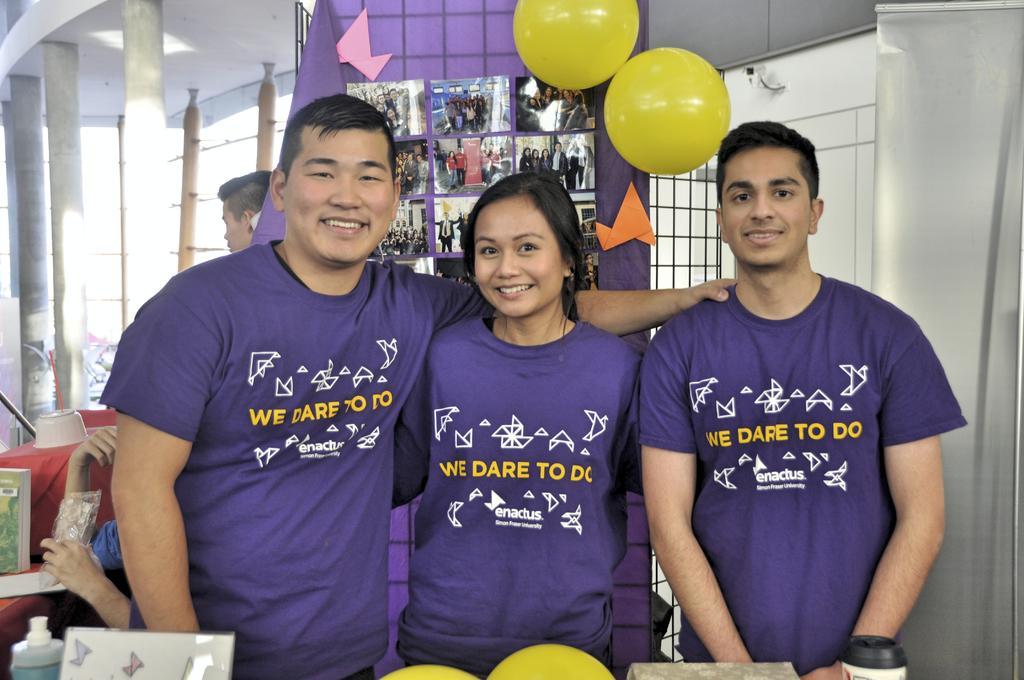Describe this image in one or two sentences. In this image in the center there are group of persons standing and smiling. In the background there are balloons which are yellow in colour and there is a curtain and on the curtain there is a banner with photos in it. In the background there is a person sitting and there are pillars and there is a table and on the table there is an object which is white in colour and there are windows. 